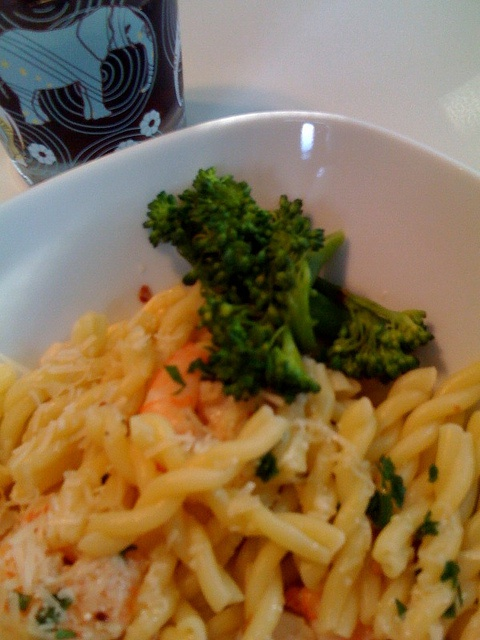Describe the objects in this image and their specific colors. I can see bowl in black, darkgray, and gray tones, broccoli in black, darkgreen, and maroon tones, cup in black, gray, teal, and blue tones, and carrot in black, brown, red, and maroon tones in this image. 